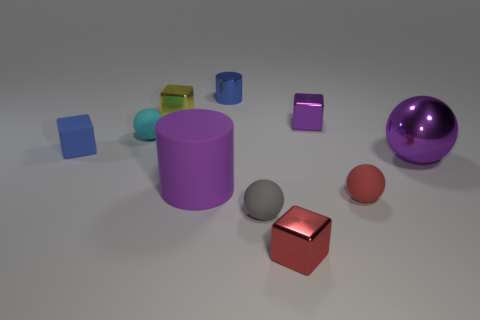There is a purple shiny thing right of the tiny purple metallic cube; what number of metal cylinders are right of it?
Your answer should be compact. 0. There is a object that is left of the blue cylinder and in front of the blue matte cube; what is its size?
Offer a terse response. Large. What is the material of the object that is behind the yellow metal cube?
Your response must be concise. Metal. Is there a brown object of the same shape as the small blue rubber object?
Your answer should be compact. No. What number of small yellow metal things have the same shape as the cyan matte thing?
Ensure brevity in your answer.  0. There is a metal thing right of the small purple thing; is its size the same as the object that is left of the tiny cyan matte sphere?
Your response must be concise. No. There is a tiny blue thing that is right of the sphere to the left of the tiny yellow object; what is its shape?
Your answer should be compact. Cylinder. Are there an equal number of metal spheres behind the large ball and large blocks?
Give a very brief answer. Yes. What is the material of the small block in front of the small blue object that is left of the small sphere to the left of the tiny shiny cylinder?
Provide a short and direct response. Metal. Is there a red rubber thing of the same size as the metal sphere?
Provide a short and direct response. No. 